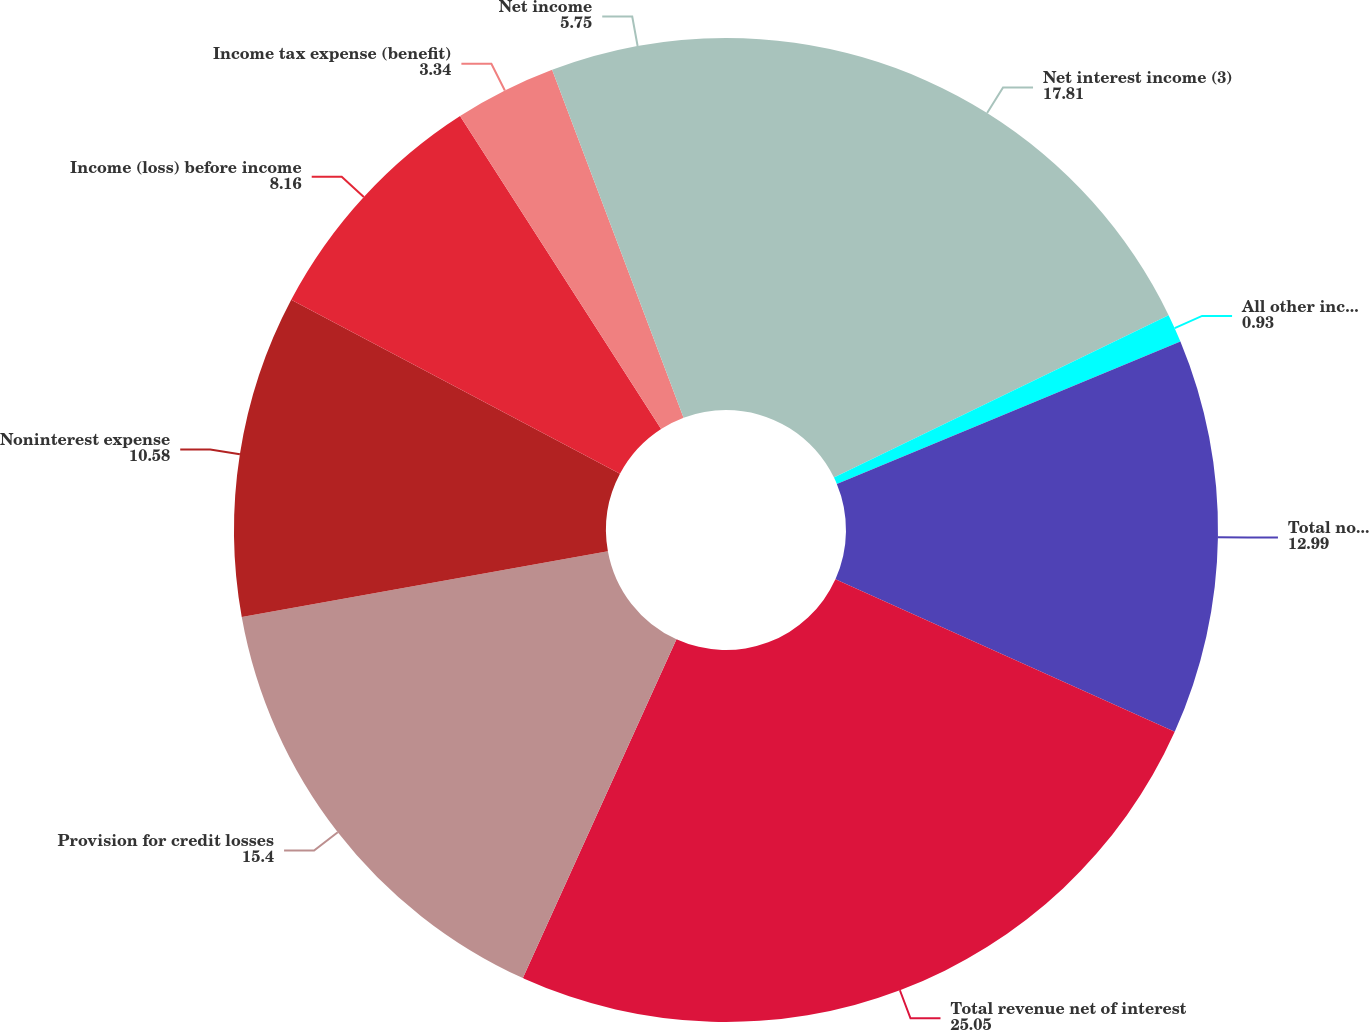Convert chart. <chart><loc_0><loc_0><loc_500><loc_500><pie_chart><fcel>Net interest income (3)<fcel>All other income<fcel>Total noninterest income<fcel>Total revenue net of interest<fcel>Provision for credit losses<fcel>Noninterest expense<fcel>Income (loss) before income<fcel>Income tax expense (benefit)<fcel>Net income<nl><fcel>17.81%<fcel>0.93%<fcel>12.99%<fcel>25.05%<fcel>15.4%<fcel>10.58%<fcel>8.16%<fcel>3.34%<fcel>5.75%<nl></chart> 